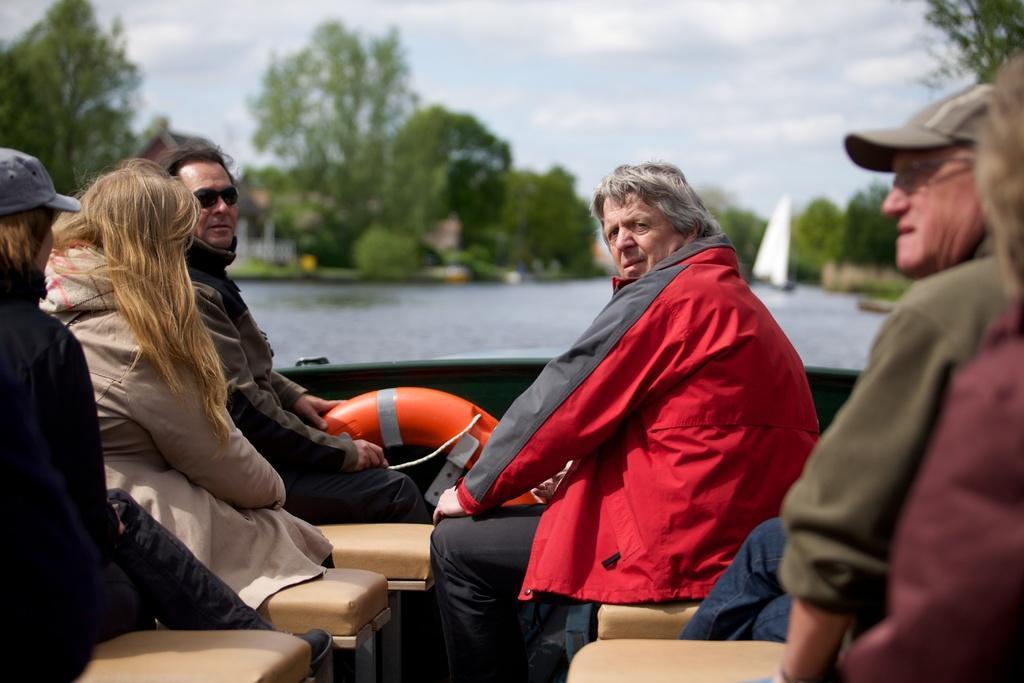Can you describe this image briefly? There are persons in different color dresses, sitting on the benches, which are in the boat. The boat is on the water of a river. In the background, there is another boat on the water, there are trees, a building and clouds in the blue sky. 